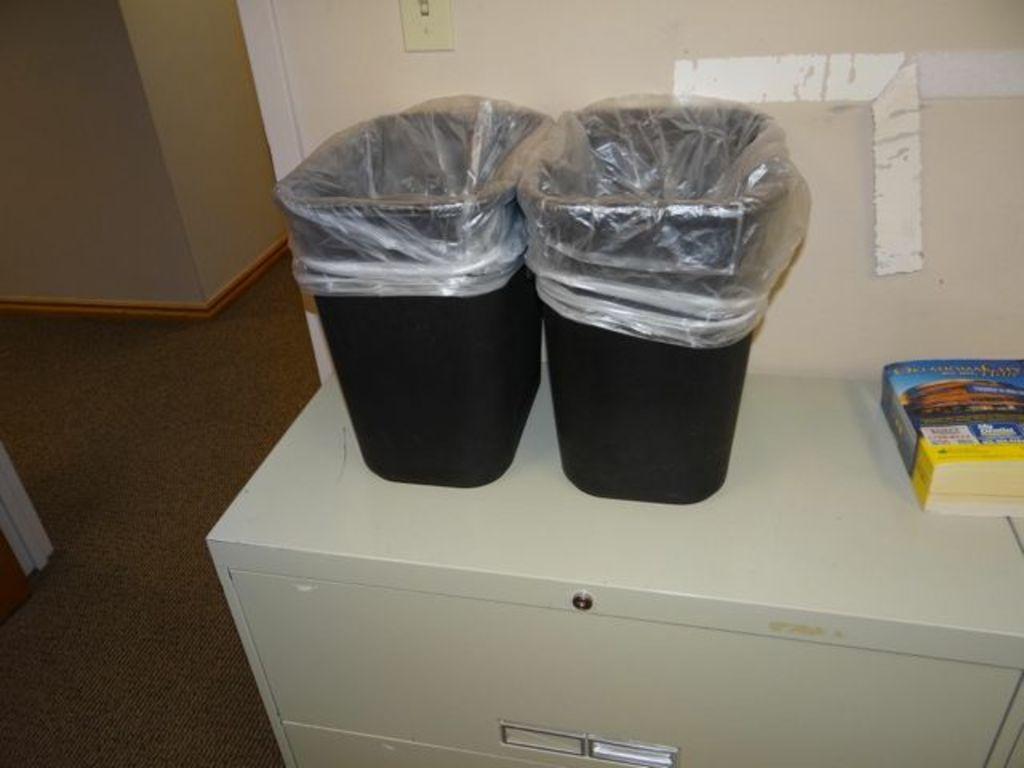Describe this image in one or two sentences. In this image we can see two black color bins with covers and there is a book on the top of a shelf. In the background we can see the switch board attached to the wall. We can also see the floor. 